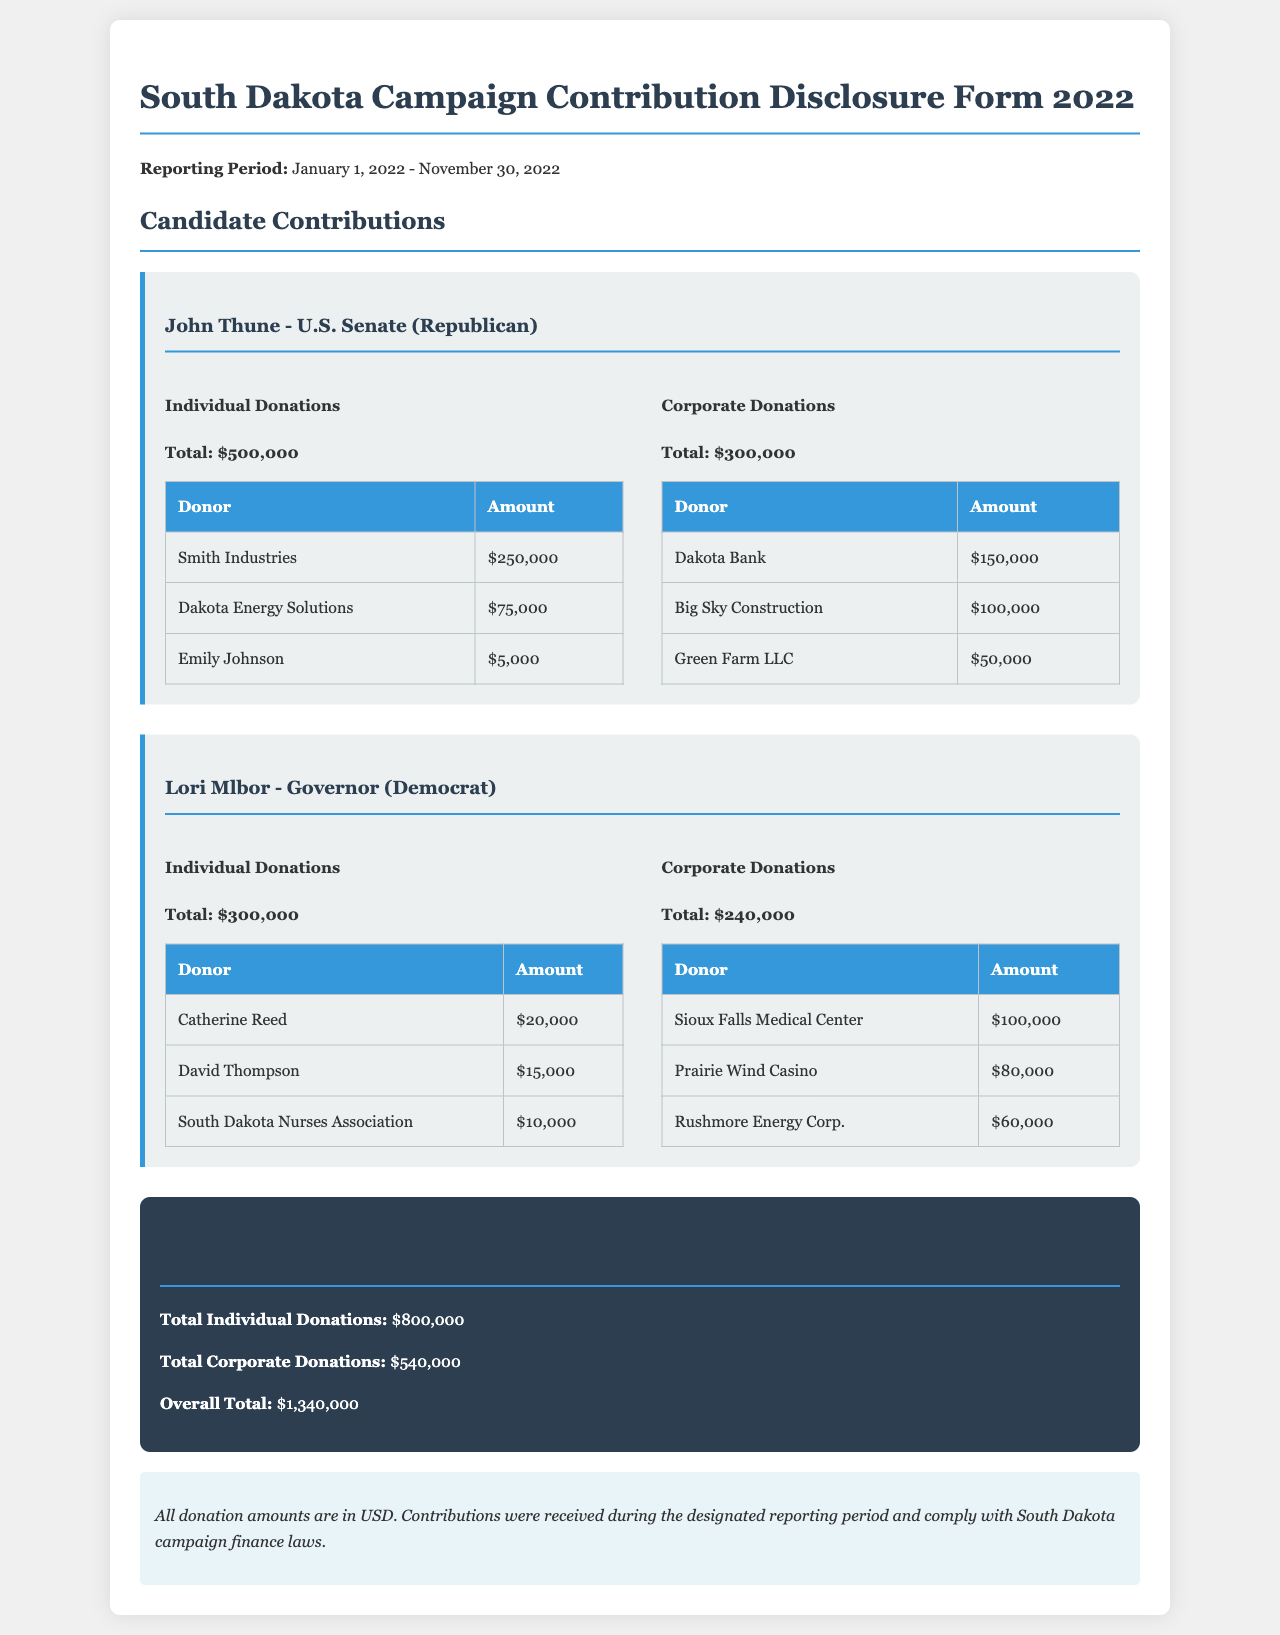What is the total amount of individual donations received by John Thune? The total individual donations for John Thune is presented in the document as $500,000.
Answer: $500,000 Who is the highest corporate donor to Lori Mlbor's campaign? The highest corporate donor listed for Lori Mlbor is Sioux Falls Medical Center with a donation of $100,000.
Answer: Sioux Falls Medical Center What is the overall total of contributions reported in the document? The overall total contributions is provided as $1,340,000, representing the sum of all donations.
Answer: $1,340,000 How much did Dakota Energy Solutions donate to John Thune? The donation amount from Dakota Energy Solutions is specifically stated as $75,000 in the document.
Answer: $75,000 What percentage of total contributions came from corporate donations? The total corporate donations are $540,000, and calculating the percentage from the overall total gives us (540,000 / 1,340,000) * 100, which is about 40.3%.
Answer: 40.3% Which candidate received more total contributions, John Thune or Lori Mlbor? By comparing the total contributions, John Thune's total is $800,000 (individual + corporate), while Lori Mlbor's is $540,000.
Answer: John Thune What is the total amount of donations received by Lori Mlbor? The total amount of donations received by Lori Mlbor is on record as $540,000, calculated from both individual and corporate contributions.
Answer: $540,000 What is the total of individual donations listed for Lori Mlbor? The total for individual donations to Lori Mlbor sums up to $300,000 as stated in the document.
Answer: $300,000 Which type of donation (individual or corporate) contributed more to John Thune's campaign? The document specifies John Thune received $500,000 in individual donations and $300,000 in corporate donations, making individual donations higher.
Answer: Individual donations 